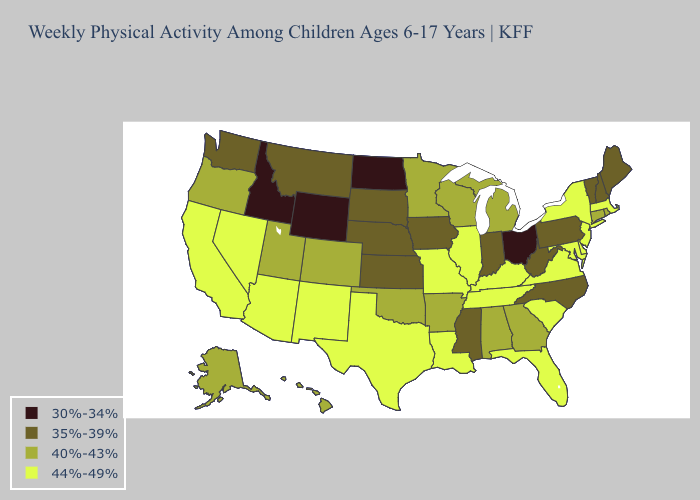Name the states that have a value in the range 44%-49%?
Give a very brief answer. Arizona, California, Delaware, Florida, Illinois, Kentucky, Louisiana, Maryland, Massachusetts, Missouri, Nevada, New Jersey, New Mexico, New York, South Carolina, Tennessee, Texas, Virginia. Does Ohio have the lowest value in the USA?
Concise answer only. Yes. Which states hav the highest value in the MidWest?
Give a very brief answer. Illinois, Missouri. Is the legend a continuous bar?
Concise answer only. No. What is the highest value in the MidWest ?
Short answer required. 44%-49%. What is the value of Louisiana?
Short answer required. 44%-49%. Among the states that border Nevada , does Idaho have the lowest value?
Concise answer only. Yes. Among the states that border Colorado , does Wyoming have the lowest value?
Give a very brief answer. Yes. How many symbols are there in the legend?
Concise answer only. 4. Among the states that border South Carolina , which have the highest value?
Be succinct. Georgia. Name the states that have a value in the range 40%-43%?
Answer briefly. Alabama, Alaska, Arkansas, Colorado, Connecticut, Georgia, Hawaii, Michigan, Minnesota, Oklahoma, Oregon, Rhode Island, Utah, Wisconsin. Which states hav the highest value in the West?
Be succinct. Arizona, California, Nevada, New Mexico. How many symbols are there in the legend?
Write a very short answer. 4. Which states hav the highest value in the Northeast?
Answer briefly. Massachusetts, New Jersey, New York. What is the value of Delaware?
Be succinct. 44%-49%. 